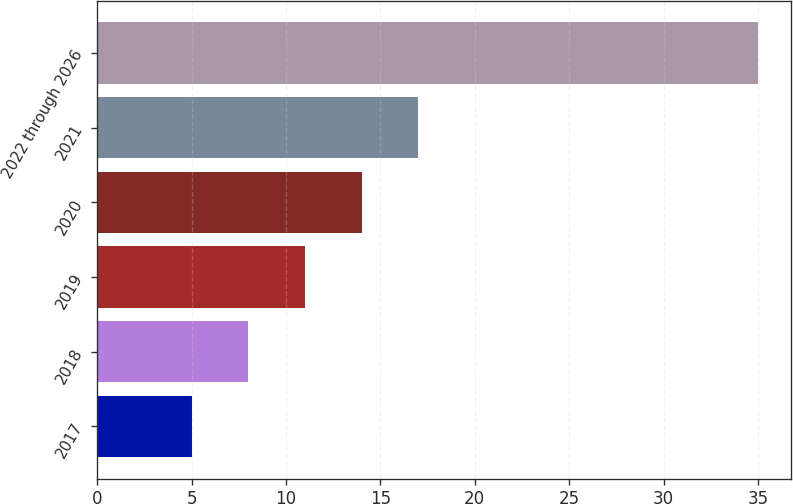<chart> <loc_0><loc_0><loc_500><loc_500><bar_chart><fcel>2017<fcel>2018<fcel>2019<fcel>2020<fcel>2021<fcel>2022 through 2026<nl><fcel>5<fcel>8<fcel>11<fcel>14<fcel>17<fcel>35<nl></chart> 